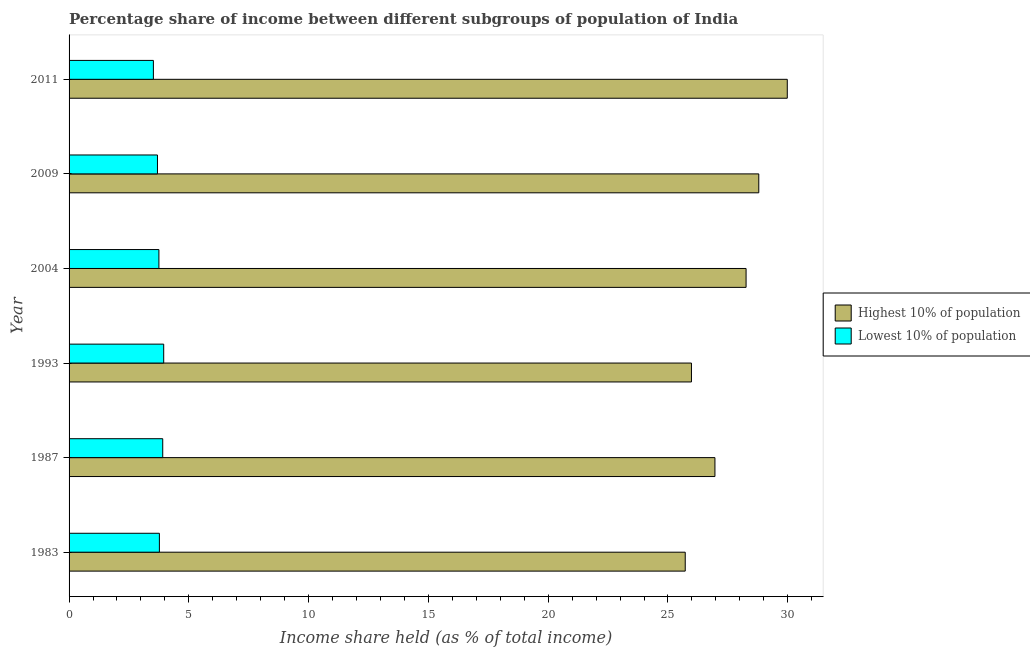How many groups of bars are there?
Give a very brief answer. 6. How many bars are there on the 6th tick from the top?
Your answer should be compact. 2. What is the income share held by highest 10% of the population in 2009?
Give a very brief answer. 28.79. Across all years, what is the maximum income share held by highest 10% of the population?
Keep it short and to the point. 29.98. Across all years, what is the minimum income share held by lowest 10% of the population?
Keep it short and to the point. 3.52. In which year was the income share held by lowest 10% of the population minimum?
Offer a very short reply. 2011. What is the total income share held by lowest 10% of the population in the graph?
Your answer should be very brief. 22.59. What is the difference between the income share held by lowest 10% of the population in 1987 and that in 2004?
Offer a very short reply. 0.16. What is the difference between the income share held by highest 10% of the population in 1993 and the income share held by lowest 10% of the population in 2004?
Keep it short and to the point. 22.23. What is the average income share held by lowest 10% of the population per year?
Offer a terse response. 3.77. In the year 1993, what is the difference between the income share held by highest 10% of the population and income share held by lowest 10% of the population?
Keep it short and to the point. 22.03. In how many years, is the income share held by lowest 10% of the population greater than 25 %?
Give a very brief answer. 0. Is the income share held by highest 10% of the population in 1983 less than that in 2009?
Keep it short and to the point. Yes. Is the difference between the income share held by lowest 10% of the population in 1983 and 2011 greater than the difference between the income share held by highest 10% of the population in 1983 and 2011?
Ensure brevity in your answer.  Yes. What is the difference between the highest and the second highest income share held by highest 10% of the population?
Provide a succinct answer. 1.19. What is the difference between the highest and the lowest income share held by highest 10% of the population?
Your response must be concise. 4.26. In how many years, is the income share held by highest 10% of the population greater than the average income share held by highest 10% of the population taken over all years?
Your answer should be very brief. 3. What does the 1st bar from the top in 2011 represents?
Your response must be concise. Lowest 10% of population. What does the 1st bar from the bottom in 1987 represents?
Your answer should be very brief. Highest 10% of population. How many bars are there?
Give a very brief answer. 12. How many years are there in the graph?
Your response must be concise. 6. What is the difference between two consecutive major ticks on the X-axis?
Keep it short and to the point. 5. How many legend labels are there?
Offer a very short reply. 2. How are the legend labels stacked?
Provide a succinct answer. Vertical. What is the title of the graph?
Make the answer very short. Percentage share of income between different subgroups of population of India. Does "Highest 10% of population" appear as one of the legend labels in the graph?
Offer a very short reply. Yes. What is the label or title of the X-axis?
Offer a very short reply. Income share held (as % of total income). What is the label or title of the Y-axis?
Offer a very short reply. Year. What is the Income share held (as % of total income) in Highest 10% of population in 1983?
Offer a terse response. 25.72. What is the Income share held (as % of total income) of Lowest 10% of population in 1983?
Provide a short and direct response. 3.77. What is the Income share held (as % of total income) in Highest 10% of population in 1987?
Your answer should be compact. 26.96. What is the Income share held (as % of total income) in Lowest 10% of population in 1987?
Provide a succinct answer. 3.91. What is the Income share held (as % of total income) in Highest 10% of population in 1993?
Keep it short and to the point. 25.98. What is the Income share held (as % of total income) of Lowest 10% of population in 1993?
Provide a short and direct response. 3.95. What is the Income share held (as % of total income) in Highest 10% of population in 2004?
Provide a short and direct response. 28.26. What is the Income share held (as % of total income) in Lowest 10% of population in 2004?
Ensure brevity in your answer.  3.75. What is the Income share held (as % of total income) in Highest 10% of population in 2009?
Give a very brief answer. 28.79. What is the Income share held (as % of total income) in Lowest 10% of population in 2009?
Offer a very short reply. 3.69. What is the Income share held (as % of total income) in Highest 10% of population in 2011?
Make the answer very short. 29.98. What is the Income share held (as % of total income) of Lowest 10% of population in 2011?
Offer a terse response. 3.52. Across all years, what is the maximum Income share held (as % of total income) of Highest 10% of population?
Offer a very short reply. 29.98. Across all years, what is the maximum Income share held (as % of total income) in Lowest 10% of population?
Your response must be concise. 3.95. Across all years, what is the minimum Income share held (as % of total income) in Highest 10% of population?
Ensure brevity in your answer.  25.72. Across all years, what is the minimum Income share held (as % of total income) of Lowest 10% of population?
Your response must be concise. 3.52. What is the total Income share held (as % of total income) in Highest 10% of population in the graph?
Provide a short and direct response. 165.69. What is the total Income share held (as % of total income) of Lowest 10% of population in the graph?
Ensure brevity in your answer.  22.59. What is the difference between the Income share held (as % of total income) of Highest 10% of population in 1983 and that in 1987?
Provide a succinct answer. -1.24. What is the difference between the Income share held (as % of total income) in Lowest 10% of population in 1983 and that in 1987?
Your answer should be compact. -0.14. What is the difference between the Income share held (as % of total income) of Highest 10% of population in 1983 and that in 1993?
Offer a very short reply. -0.26. What is the difference between the Income share held (as % of total income) in Lowest 10% of population in 1983 and that in 1993?
Keep it short and to the point. -0.18. What is the difference between the Income share held (as % of total income) in Highest 10% of population in 1983 and that in 2004?
Provide a succinct answer. -2.54. What is the difference between the Income share held (as % of total income) in Highest 10% of population in 1983 and that in 2009?
Your response must be concise. -3.07. What is the difference between the Income share held (as % of total income) in Highest 10% of population in 1983 and that in 2011?
Keep it short and to the point. -4.26. What is the difference between the Income share held (as % of total income) of Lowest 10% of population in 1983 and that in 2011?
Keep it short and to the point. 0.25. What is the difference between the Income share held (as % of total income) in Lowest 10% of population in 1987 and that in 1993?
Offer a terse response. -0.04. What is the difference between the Income share held (as % of total income) in Highest 10% of population in 1987 and that in 2004?
Offer a terse response. -1.3. What is the difference between the Income share held (as % of total income) of Lowest 10% of population in 1987 and that in 2004?
Provide a succinct answer. 0.16. What is the difference between the Income share held (as % of total income) in Highest 10% of population in 1987 and that in 2009?
Offer a very short reply. -1.83. What is the difference between the Income share held (as % of total income) in Lowest 10% of population in 1987 and that in 2009?
Offer a very short reply. 0.22. What is the difference between the Income share held (as % of total income) in Highest 10% of population in 1987 and that in 2011?
Your answer should be compact. -3.02. What is the difference between the Income share held (as % of total income) in Lowest 10% of population in 1987 and that in 2011?
Offer a very short reply. 0.39. What is the difference between the Income share held (as % of total income) of Highest 10% of population in 1993 and that in 2004?
Your answer should be very brief. -2.28. What is the difference between the Income share held (as % of total income) of Highest 10% of population in 1993 and that in 2009?
Make the answer very short. -2.81. What is the difference between the Income share held (as % of total income) in Lowest 10% of population in 1993 and that in 2009?
Your answer should be very brief. 0.26. What is the difference between the Income share held (as % of total income) of Highest 10% of population in 1993 and that in 2011?
Your answer should be very brief. -4. What is the difference between the Income share held (as % of total income) of Lowest 10% of population in 1993 and that in 2011?
Keep it short and to the point. 0.43. What is the difference between the Income share held (as % of total income) of Highest 10% of population in 2004 and that in 2009?
Your answer should be compact. -0.53. What is the difference between the Income share held (as % of total income) in Lowest 10% of population in 2004 and that in 2009?
Offer a very short reply. 0.06. What is the difference between the Income share held (as % of total income) in Highest 10% of population in 2004 and that in 2011?
Ensure brevity in your answer.  -1.72. What is the difference between the Income share held (as % of total income) in Lowest 10% of population in 2004 and that in 2011?
Give a very brief answer. 0.23. What is the difference between the Income share held (as % of total income) in Highest 10% of population in 2009 and that in 2011?
Make the answer very short. -1.19. What is the difference between the Income share held (as % of total income) in Lowest 10% of population in 2009 and that in 2011?
Give a very brief answer. 0.17. What is the difference between the Income share held (as % of total income) of Highest 10% of population in 1983 and the Income share held (as % of total income) of Lowest 10% of population in 1987?
Offer a very short reply. 21.81. What is the difference between the Income share held (as % of total income) of Highest 10% of population in 1983 and the Income share held (as % of total income) of Lowest 10% of population in 1993?
Offer a terse response. 21.77. What is the difference between the Income share held (as % of total income) in Highest 10% of population in 1983 and the Income share held (as % of total income) in Lowest 10% of population in 2004?
Your answer should be compact. 21.97. What is the difference between the Income share held (as % of total income) in Highest 10% of population in 1983 and the Income share held (as % of total income) in Lowest 10% of population in 2009?
Your response must be concise. 22.03. What is the difference between the Income share held (as % of total income) in Highest 10% of population in 1983 and the Income share held (as % of total income) in Lowest 10% of population in 2011?
Your response must be concise. 22.2. What is the difference between the Income share held (as % of total income) in Highest 10% of population in 1987 and the Income share held (as % of total income) in Lowest 10% of population in 1993?
Your response must be concise. 23.01. What is the difference between the Income share held (as % of total income) in Highest 10% of population in 1987 and the Income share held (as % of total income) in Lowest 10% of population in 2004?
Keep it short and to the point. 23.21. What is the difference between the Income share held (as % of total income) in Highest 10% of population in 1987 and the Income share held (as % of total income) in Lowest 10% of population in 2009?
Ensure brevity in your answer.  23.27. What is the difference between the Income share held (as % of total income) of Highest 10% of population in 1987 and the Income share held (as % of total income) of Lowest 10% of population in 2011?
Keep it short and to the point. 23.44. What is the difference between the Income share held (as % of total income) in Highest 10% of population in 1993 and the Income share held (as % of total income) in Lowest 10% of population in 2004?
Keep it short and to the point. 22.23. What is the difference between the Income share held (as % of total income) of Highest 10% of population in 1993 and the Income share held (as % of total income) of Lowest 10% of population in 2009?
Give a very brief answer. 22.29. What is the difference between the Income share held (as % of total income) in Highest 10% of population in 1993 and the Income share held (as % of total income) in Lowest 10% of population in 2011?
Offer a very short reply. 22.46. What is the difference between the Income share held (as % of total income) of Highest 10% of population in 2004 and the Income share held (as % of total income) of Lowest 10% of population in 2009?
Offer a terse response. 24.57. What is the difference between the Income share held (as % of total income) in Highest 10% of population in 2004 and the Income share held (as % of total income) in Lowest 10% of population in 2011?
Your response must be concise. 24.74. What is the difference between the Income share held (as % of total income) in Highest 10% of population in 2009 and the Income share held (as % of total income) in Lowest 10% of population in 2011?
Ensure brevity in your answer.  25.27. What is the average Income share held (as % of total income) of Highest 10% of population per year?
Ensure brevity in your answer.  27.61. What is the average Income share held (as % of total income) of Lowest 10% of population per year?
Offer a very short reply. 3.77. In the year 1983, what is the difference between the Income share held (as % of total income) in Highest 10% of population and Income share held (as % of total income) in Lowest 10% of population?
Ensure brevity in your answer.  21.95. In the year 1987, what is the difference between the Income share held (as % of total income) in Highest 10% of population and Income share held (as % of total income) in Lowest 10% of population?
Your answer should be compact. 23.05. In the year 1993, what is the difference between the Income share held (as % of total income) in Highest 10% of population and Income share held (as % of total income) in Lowest 10% of population?
Ensure brevity in your answer.  22.03. In the year 2004, what is the difference between the Income share held (as % of total income) of Highest 10% of population and Income share held (as % of total income) of Lowest 10% of population?
Ensure brevity in your answer.  24.51. In the year 2009, what is the difference between the Income share held (as % of total income) in Highest 10% of population and Income share held (as % of total income) in Lowest 10% of population?
Offer a terse response. 25.1. In the year 2011, what is the difference between the Income share held (as % of total income) in Highest 10% of population and Income share held (as % of total income) in Lowest 10% of population?
Ensure brevity in your answer.  26.46. What is the ratio of the Income share held (as % of total income) in Highest 10% of population in 1983 to that in 1987?
Offer a terse response. 0.95. What is the ratio of the Income share held (as % of total income) of Lowest 10% of population in 1983 to that in 1987?
Your answer should be very brief. 0.96. What is the ratio of the Income share held (as % of total income) in Lowest 10% of population in 1983 to that in 1993?
Provide a short and direct response. 0.95. What is the ratio of the Income share held (as % of total income) of Highest 10% of population in 1983 to that in 2004?
Your response must be concise. 0.91. What is the ratio of the Income share held (as % of total income) in Highest 10% of population in 1983 to that in 2009?
Provide a short and direct response. 0.89. What is the ratio of the Income share held (as % of total income) of Lowest 10% of population in 1983 to that in 2009?
Provide a succinct answer. 1.02. What is the ratio of the Income share held (as % of total income) of Highest 10% of population in 1983 to that in 2011?
Your answer should be very brief. 0.86. What is the ratio of the Income share held (as % of total income) in Lowest 10% of population in 1983 to that in 2011?
Ensure brevity in your answer.  1.07. What is the ratio of the Income share held (as % of total income) in Highest 10% of population in 1987 to that in 1993?
Offer a terse response. 1.04. What is the ratio of the Income share held (as % of total income) of Lowest 10% of population in 1987 to that in 1993?
Your answer should be very brief. 0.99. What is the ratio of the Income share held (as % of total income) of Highest 10% of population in 1987 to that in 2004?
Offer a terse response. 0.95. What is the ratio of the Income share held (as % of total income) of Lowest 10% of population in 1987 to that in 2004?
Provide a short and direct response. 1.04. What is the ratio of the Income share held (as % of total income) in Highest 10% of population in 1987 to that in 2009?
Ensure brevity in your answer.  0.94. What is the ratio of the Income share held (as % of total income) of Lowest 10% of population in 1987 to that in 2009?
Provide a succinct answer. 1.06. What is the ratio of the Income share held (as % of total income) of Highest 10% of population in 1987 to that in 2011?
Offer a terse response. 0.9. What is the ratio of the Income share held (as % of total income) of Lowest 10% of population in 1987 to that in 2011?
Offer a very short reply. 1.11. What is the ratio of the Income share held (as % of total income) of Highest 10% of population in 1993 to that in 2004?
Give a very brief answer. 0.92. What is the ratio of the Income share held (as % of total income) of Lowest 10% of population in 1993 to that in 2004?
Provide a succinct answer. 1.05. What is the ratio of the Income share held (as % of total income) of Highest 10% of population in 1993 to that in 2009?
Offer a very short reply. 0.9. What is the ratio of the Income share held (as % of total income) of Lowest 10% of population in 1993 to that in 2009?
Your response must be concise. 1.07. What is the ratio of the Income share held (as % of total income) in Highest 10% of population in 1993 to that in 2011?
Your answer should be compact. 0.87. What is the ratio of the Income share held (as % of total income) in Lowest 10% of population in 1993 to that in 2011?
Your response must be concise. 1.12. What is the ratio of the Income share held (as % of total income) in Highest 10% of population in 2004 to that in 2009?
Your answer should be very brief. 0.98. What is the ratio of the Income share held (as % of total income) in Lowest 10% of population in 2004 to that in 2009?
Your response must be concise. 1.02. What is the ratio of the Income share held (as % of total income) of Highest 10% of population in 2004 to that in 2011?
Offer a terse response. 0.94. What is the ratio of the Income share held (as % of total income) in Lowest 10% of population in 2004 to that in 2011?
Give a very brief answer. 1.07. What is the ratio of the Income share held (as % of total income) in Highest 10% of population in 2009 to that in 2011?
Make the answer very short. 0.96. What is the ratio of the Income share held (as % of total income) of Lowest 10% of population in 2009 to that in 2011?
Your response must be concise. 1.05. What is the difference between the highest and the second highest Income share held (as % of total income) of Highest 10% of population?
Provide a succinct answer. 1.19. What is the difference between the highest and the lowest Income share held (as % of total income) in Highest 10% of population?
Your answer should be compact. 4.26. What is the difference between the highest and the lowest Income share held (as % of total income) of Lowest 10% of population?
Your answer should be very brief. 0.43. 